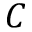<formula> <loc_0><loc_0><loc_500><loc_500>C</formula> 